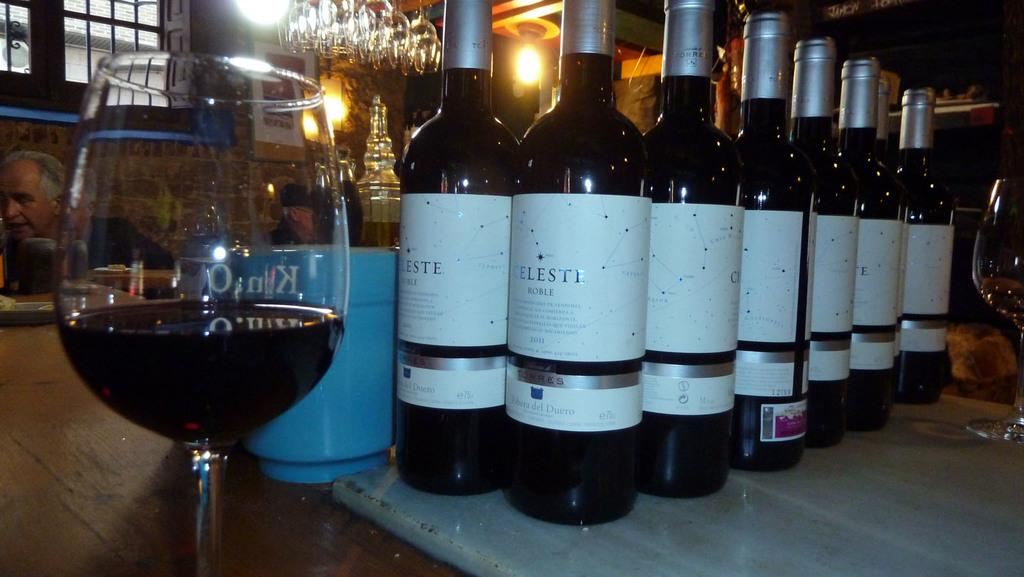<image>
Create a compact narrative representing the image presented. Two rows of Celeste wine bottles behind a glass with wine in it. 